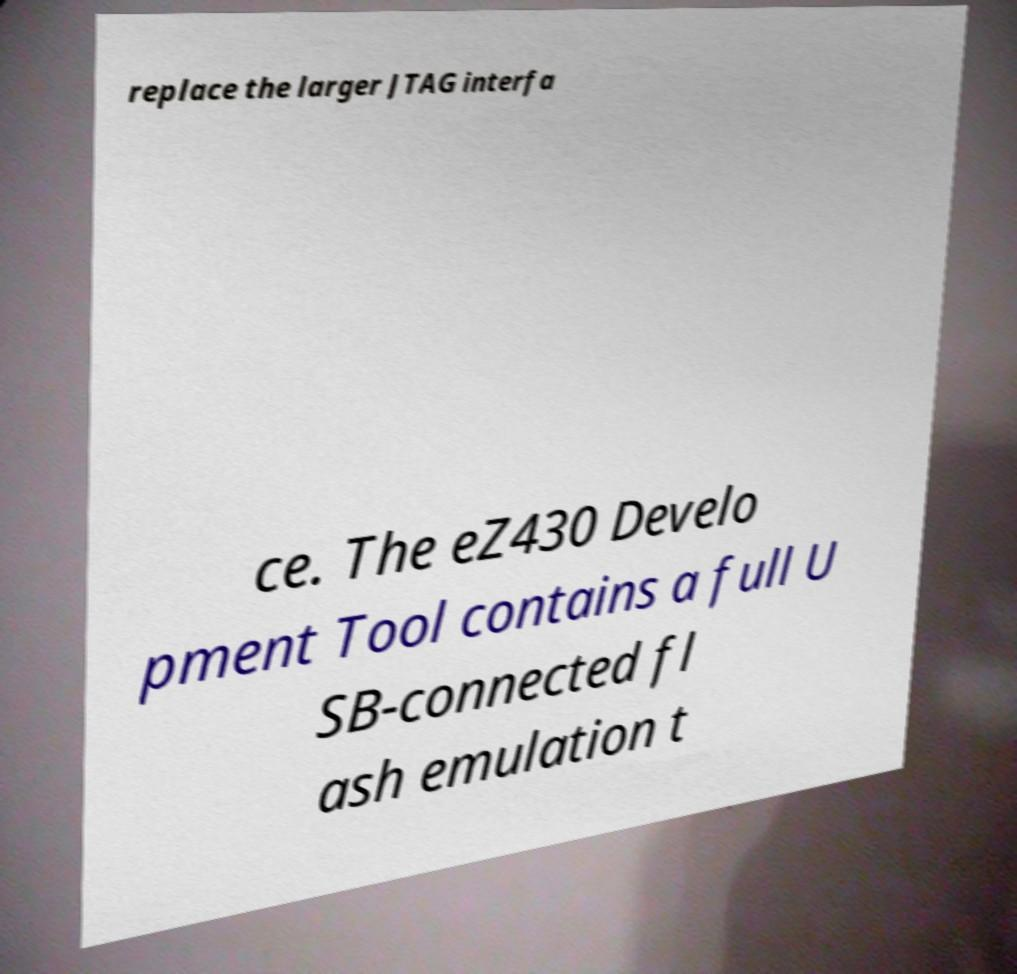Could you assist in decoding the text presented in this image and type it out clearly? replace the larger JTAG interfa ce. The eZ430 Develo pment Tool contains a full U SB-connected fl ash emulation t 